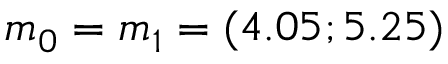<formula> <loc_0><loc_0><loc_500><loc_500>m _ { 0 } = m _ { 1 } = ( 4 . 0 5 ; 5 . 2 5 )</formula> 